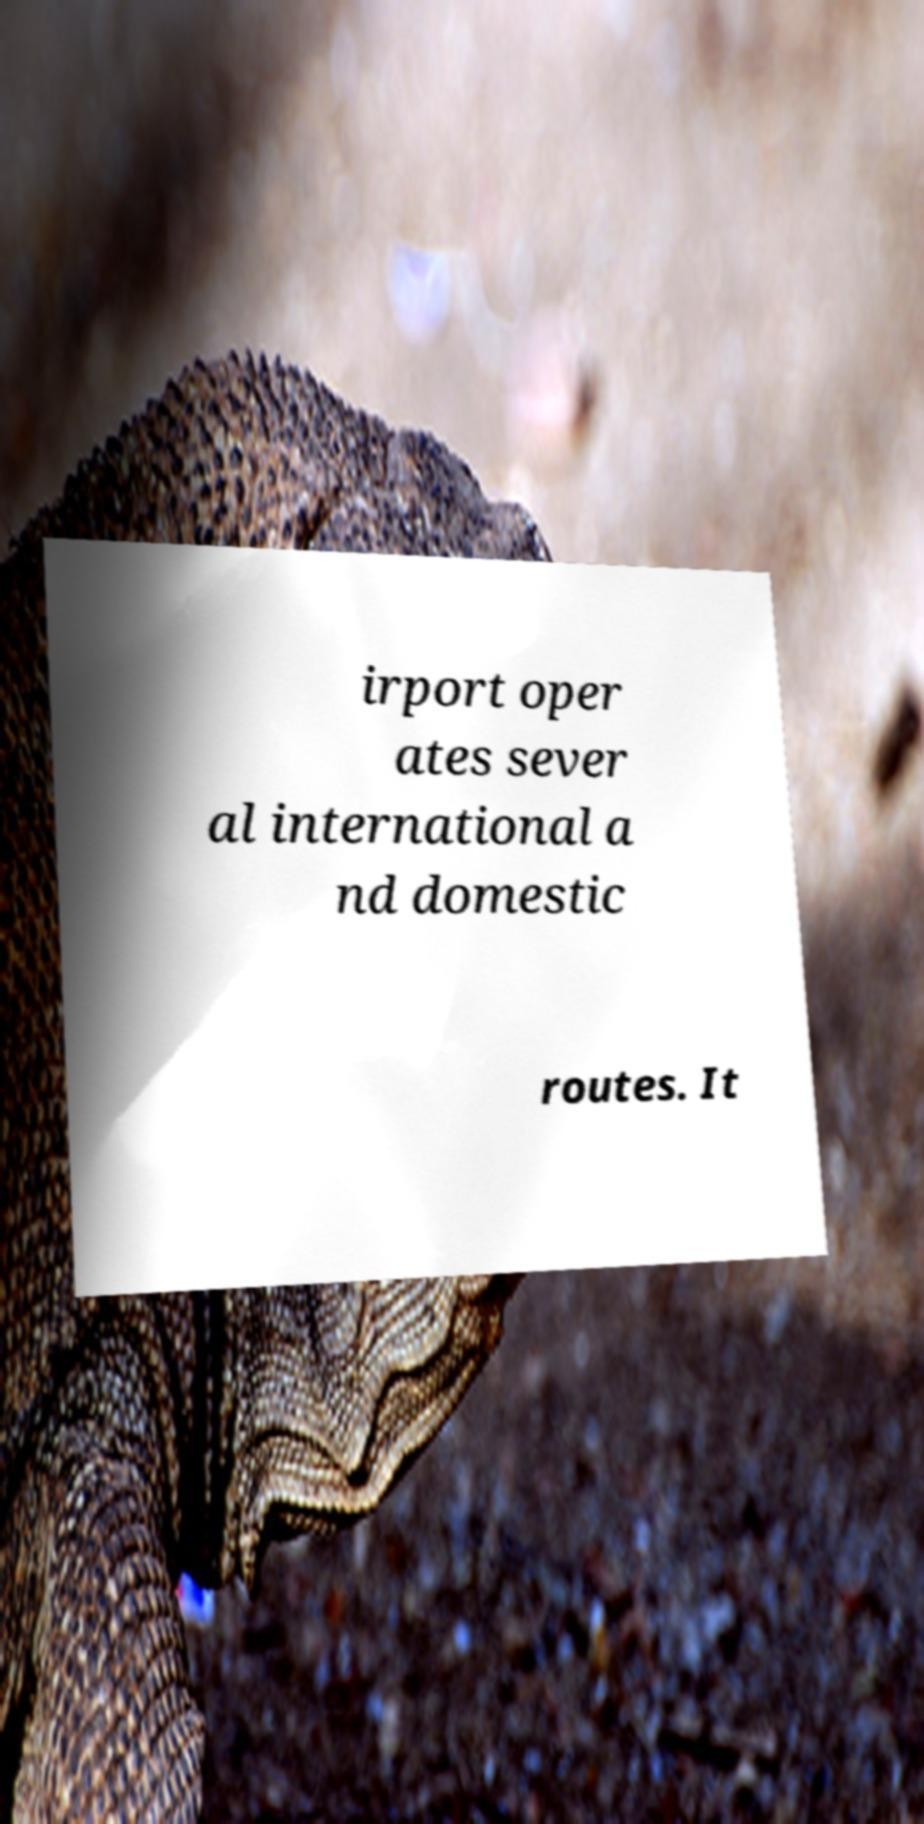What messages or text are displayed in this image? I need them in a readable, typed format. irport oper ates sever al international a nd domestic routes. It 